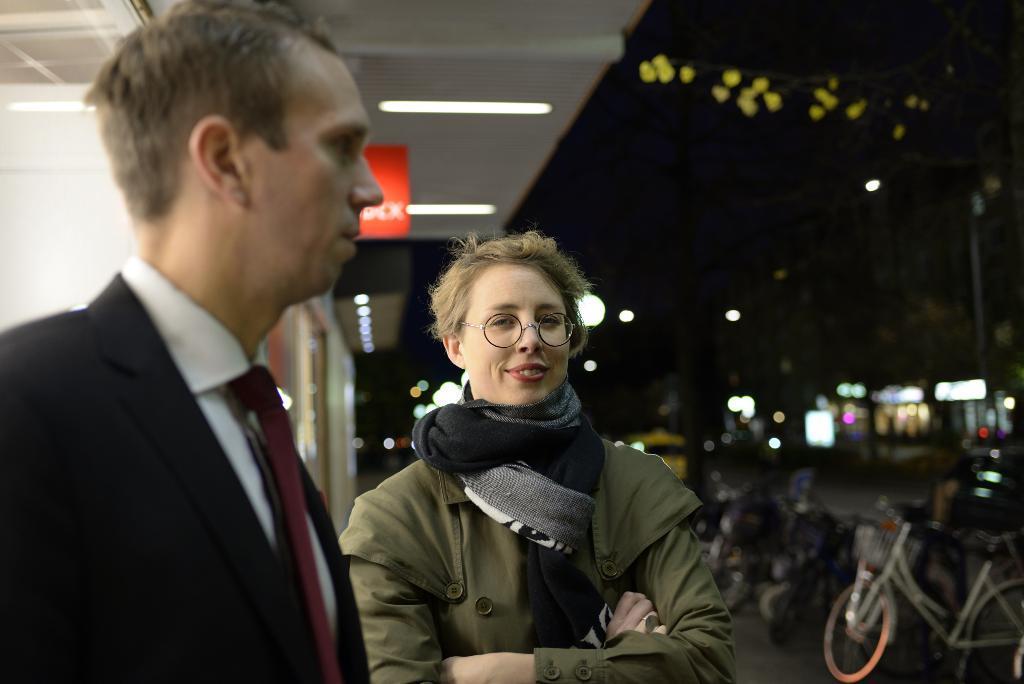In one or two sentences, can you explain what this image depicts? In this image, we can see a man and a woman standing, on the right side, we can see some bicycles and we can see some lights. 